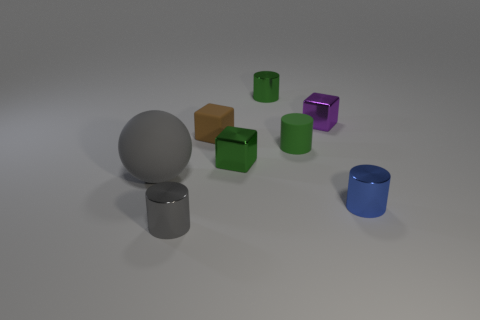Subtract 1 cylinders. How many cylinders are left? 3 Add 2 tiny cylinders. How many objects exist? 10 Subtract all balls. How many objects are left? 7 Subtract all small blue objects. Subtract all tiny red cylinders. How many objects are left? 7 Add 6 tiny matte blocks. How many tiny matte blocks are left? 7 Add 4 tiny gray metallic cylinders. How many tiny gray metallic cylinders exist? 5 Subtract 1 brown cubes. How many objects are left? 7 